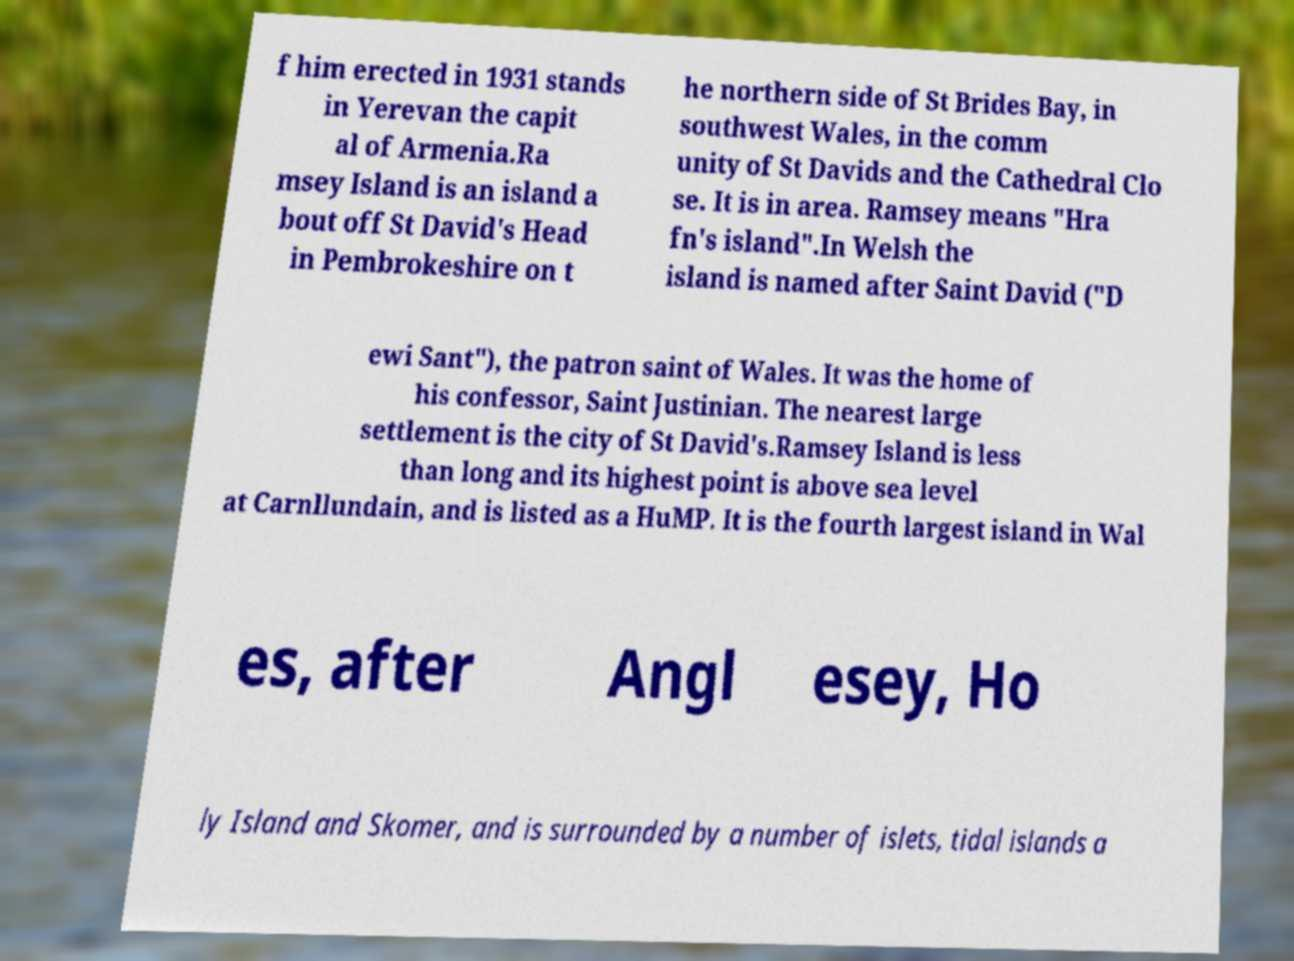What messages or text are displayed in this image? I need them in a readable, typed format. f him erected in 1931 stands in Yerevan the capit al of Armenia.Ra msey Island is an island a bout off St David's Head in Pembrokeshire on t he northern side of St Brides Bay, in southwest Wales, in the comm unity of St Davids and the Cathedral Clo se. It is in area. Ramsey means "Hra fn's island".In Welsh the island is named after Saint David ("D ewi Sant"), the patron saint of Wales. It was the home of his confessor, Saint Justinian. The nearest large settlement is the city of St David's.Ramsey Island is less than long and its highest point is above sea level at Carnllundain, and is listed as a HuMP. It is the fourth largest island in Wal es, after Angl esey, Ho ly Island and Skomer, and is surrounded by a number of islets, tidal islands a 